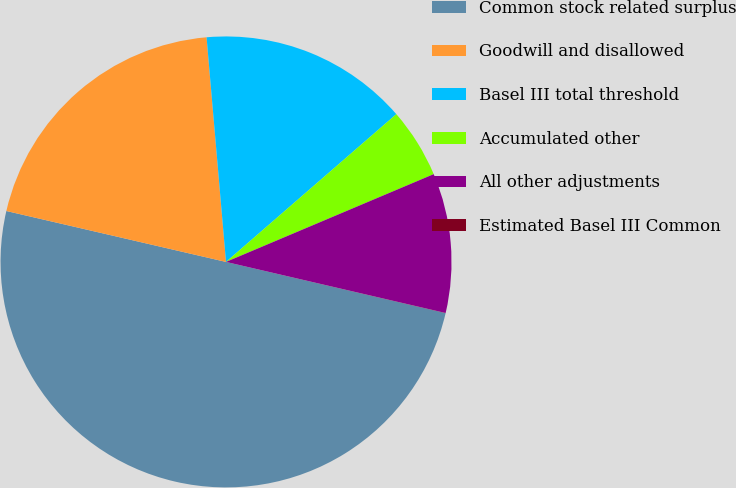Convert chart to OTSL. <chart><loc_0><loc_0><loc_500><loc_500><pie_chart><fcel>Common stock related surplus<fcel>Goodwill and disallowed<fcel>Basel III total threshold<fcel>Accumulated other<fcel>All other adjustments<fcel>Estimated Basel III Common<nl><fcel>49.98%<fcel>20.0%<fcel>15.0%<fcel>5.01%<fcel>10.0%<fcel>0.01%<nl></chart> 